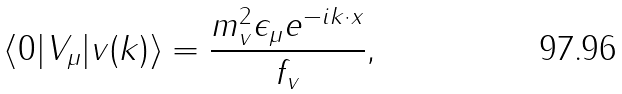Convert formula to latex. <formula><loc_0><loc_0><loc_500><loc_500>\langle 0 | V _ { \mu } | v ( k ) \rangle = \frac { m _ { v } ^ { 2 } \epsilon _ { \mu } e ^ { - i k \cdot x } } { f _ { v } } ,</formula> 